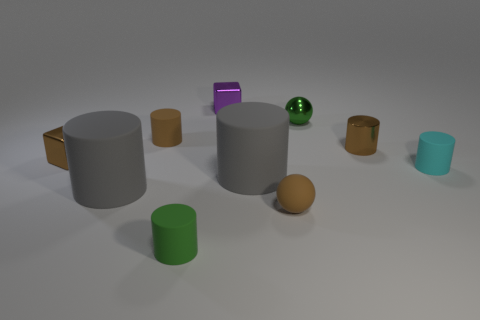How does the lighting in this scene affect the appearance of the objects? The lighting casts soft shadows and gives each object a slightly diffused look, highlighting the textures and colors of the objects. It creates a calm and balanced scene.  Can you tell which object appears to be the largest? From this perspective, the large grey cylinder in the center appears to be the largest object due to its relative size compared to the other items in the scene. 